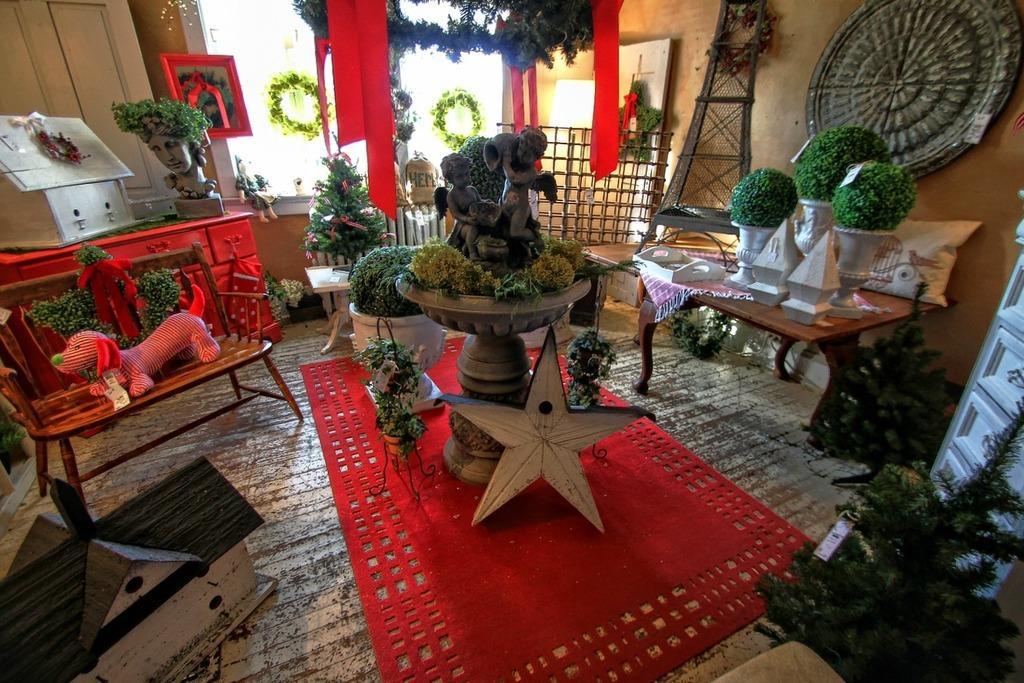Could you give a brief overview of what you see in this image? This is the picture taken in a room, this is a wooden floor on the floor there is a red mat, tables, a toy house, house plants and star. On the table there is a toy, tray, cloth. In the middle of the room there is a fountain with sculpture. Behind the sculpture there is a glass door and a wall. 